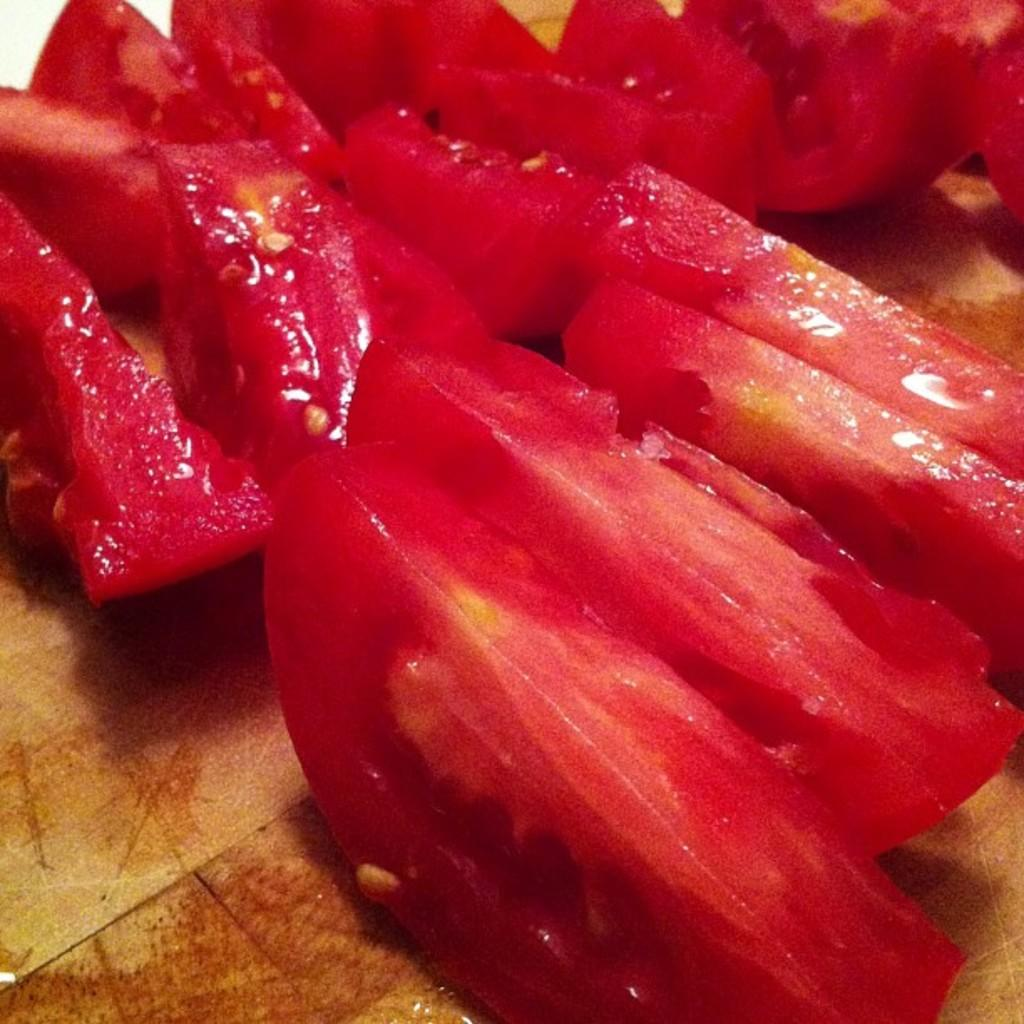What is present on the chopping board in the image? There are tomato slices on the chopping board in the image. What might the tomato slices be used for? The tomato slices might be used for cooking or preparing a meal. What degree of difficulty is the tomato slices rated in the image? The image does not provide any information about the difficulty level of the tomato slices. How does the brake system work for the tomato slices in the image? The image does not depict any brake system related to the tomato slices, as they are stationary on the chopping board. 